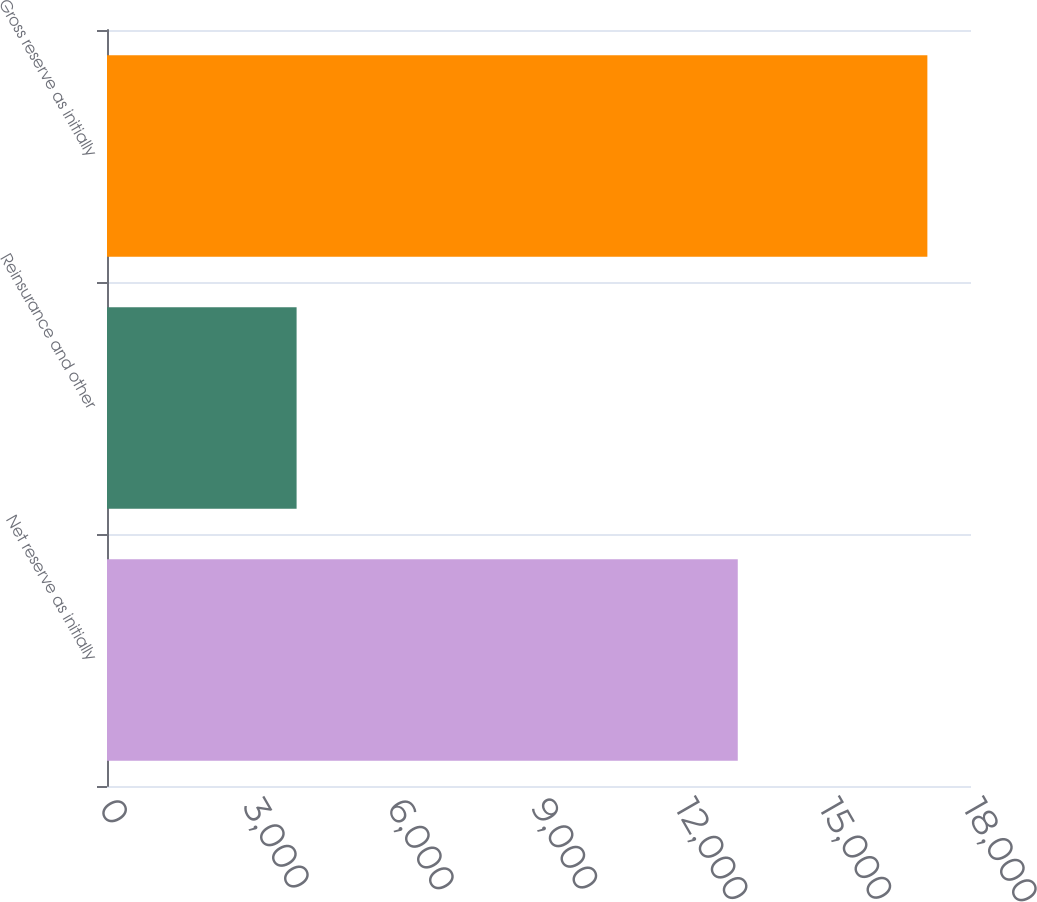Convert chart to OTSL. <chart><loc_0><loc_0><loc_500><loc_500><bar_chart><fcel>Net reserve as initially<fcel>Reinsurance and other<fcel>Gross reserve as initially<nl><fcel>13141<fcel>3950<fcel>17091<nl></chart> 